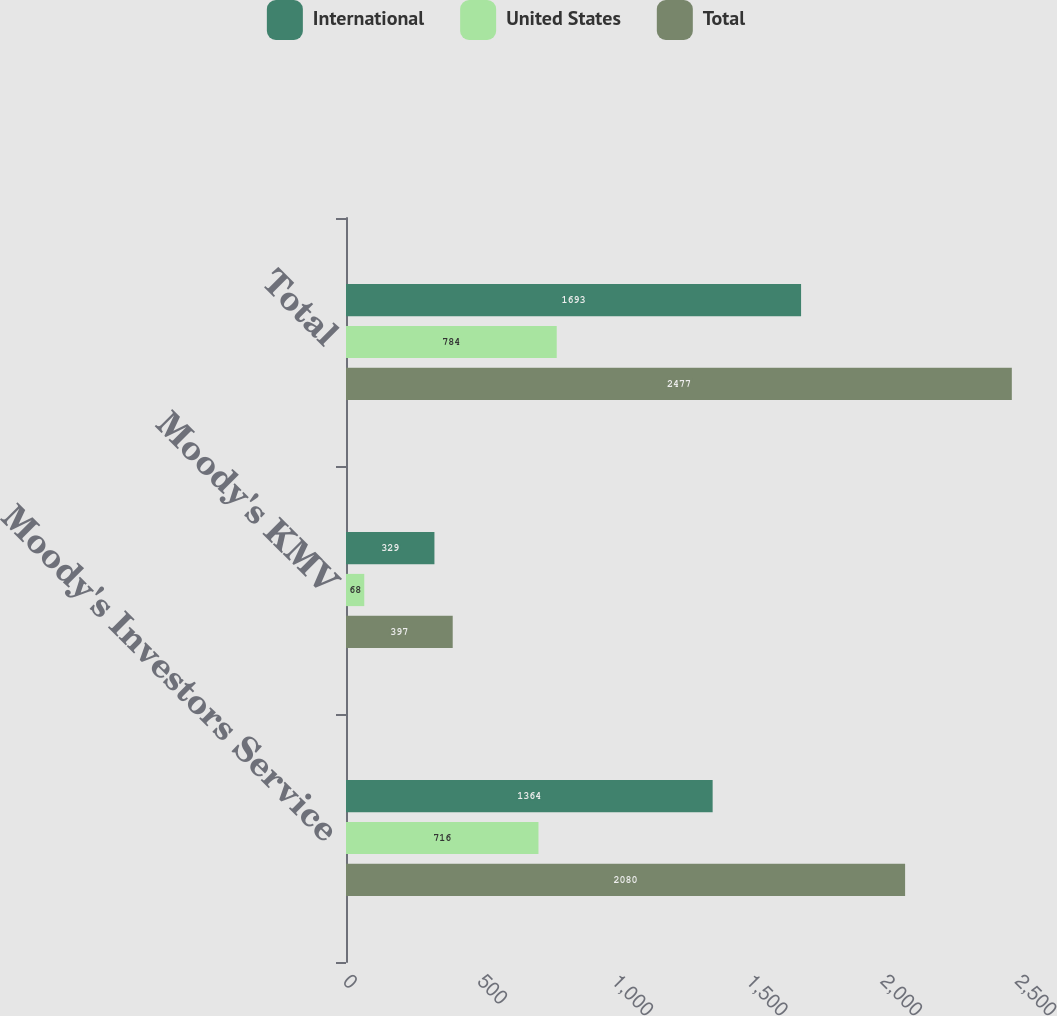Convert chart to OTSL. <chart><loc_0><loc_0><loc_500><loc_500><stacked_bar_chart><ecel><fcel>Moody's Investors Service<fcel>Moody's KMV<fcel>Total<nl><fcel>International<fcel>1364<fcel>329<fcel>1693<nl><fcel>United States<fcel>716<fcel>68<fcel>784<nl><fcel>Total<fcel>2080<fcel>397<fcel>2477<nl></chart> 